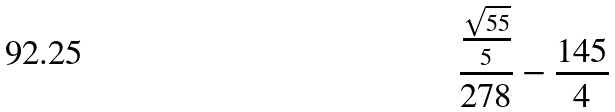Convert formula to latex. <formula><loc_0><loc_0><loc_500><loc_500>\frac { \frac { \sqrt { 5 5 } } { 5 } } { 2 7 8 } - \frac { 1 4 5 } { 4 }</formula> 